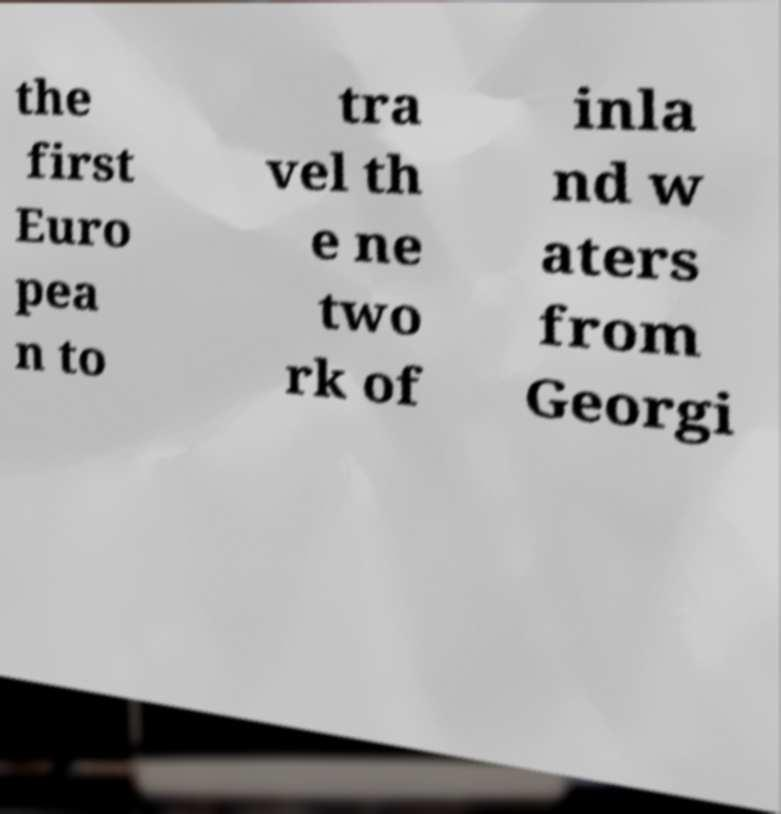I need the written content from this picture converted into text. Can you do that? the first Euro pea n to tra vel th e ne two rk of inla nd w aters from Georgi 